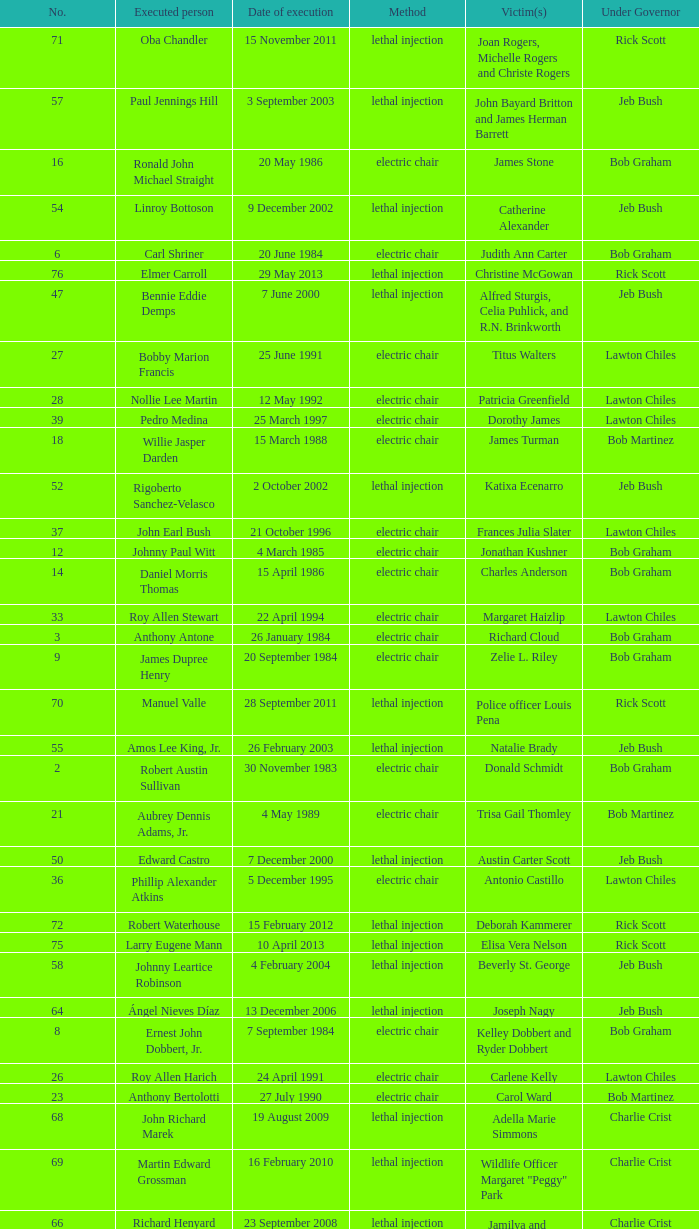What's the name of Linroy Bottoson's victim? Catherine Alexander. 